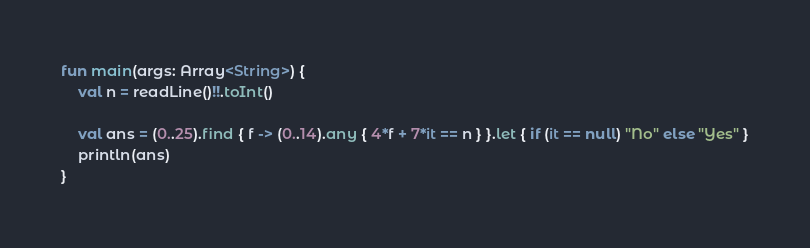Convert code to text. <code><loc_0><loc_0><loc_500><loc_500><_Kotlin_>fun main(args: Array<String>) {
    val n = readLine()!!.toInt()

    val ans = (0..25).find { f -> (0..14).any { 4*f + 7*it == n } }.let { if (it == null) "No" else "Yes" }
    println(ans)
}</code> 